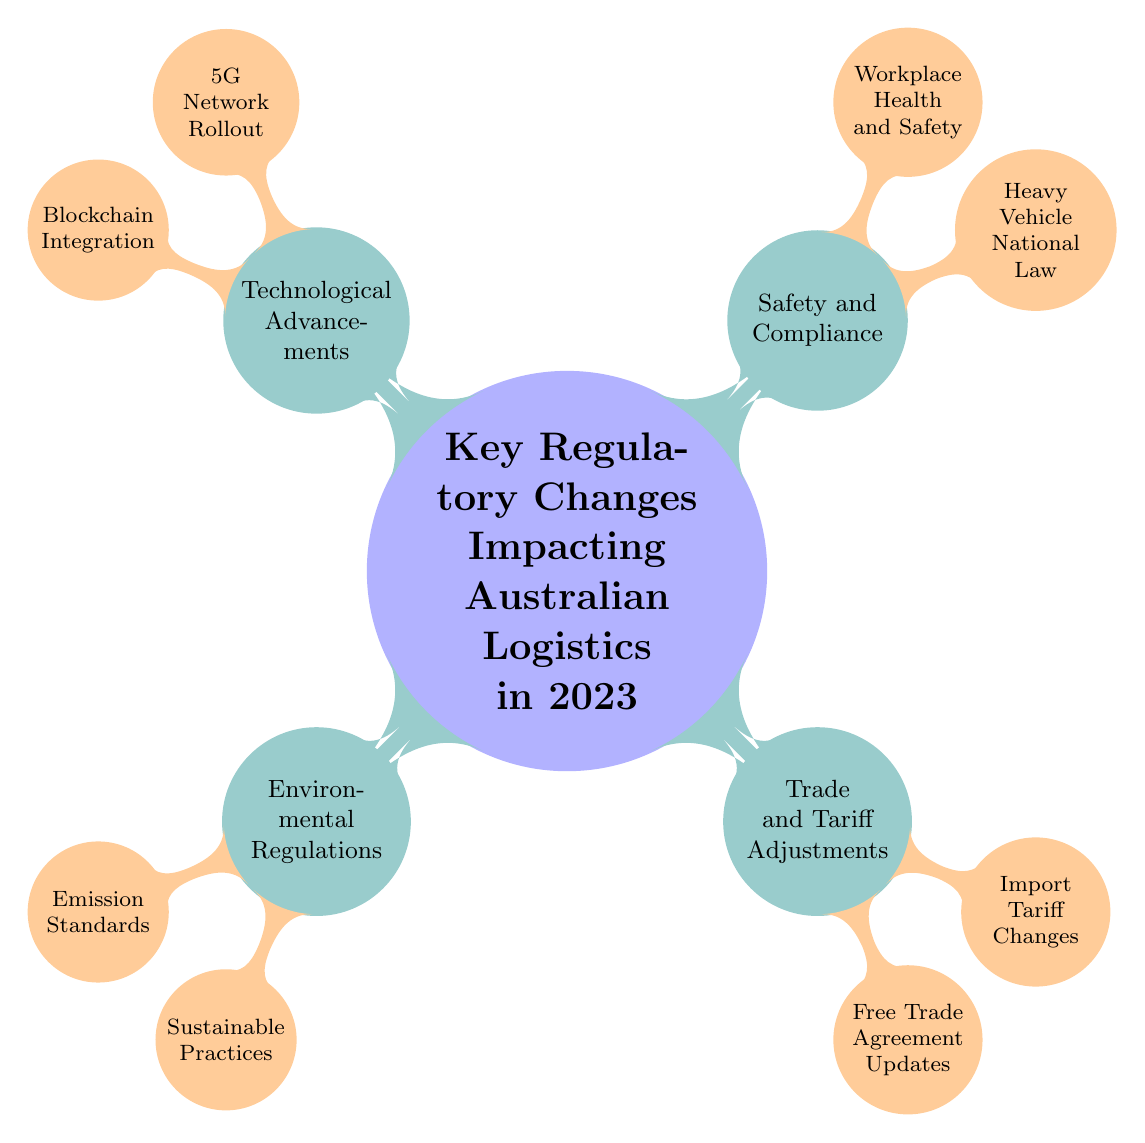What are the two main categories of regulatory changes impacting Australian logistics in 2023? The diagram shows four main categories as branches: Environmental Regulations, Trade and Tariff Adjustments, Safety and Compliance, and Technological Advancements. Therefore, mentioning any two of these categories fulfills the requirement.
Answer: Environmental Regulations, Trade and Tariff Adjustments What are the specific emission standards mentioned? The node labeled "Emission Standards" under "Environmental Regulations" refers explicitly to the National Greenhouse and Energy Reporting (NGER) Scheme. It is a direct relationship with the main category.
Answer: National Greenhouse and Energy Reporting (NGER) Scheme How many child nodes are there under "Safety and Compliance"? The node titled "Safety and Compliance" has two child nodes linked to it: Heavy Vehicle National Law and Workplace Health and Safety. Counting these child nodes gives us the answer.
Answer: 2 What regulatory framework is associated with the Heavy Vehicle National Law? Under "Safety and Compliance," the child node "Heavy Vehicle National Law" directly connects to "Changes in Chain of Responsibility (CoR) Requirements" to explain its regulatory aspect. Therefore, understanding this structure leads to the answer.
Answer: Changes in Chain of Responsibility (CoR) Requirements Which technological advancement is linked to freight tracking? The node "Blockchain Integration" under "Technological Advancements" is specifically associated with the adoption of blockchain technology in freight tracking and documentation, establishing a clear connection in the mind map.
Answer: Blockchain Integration 